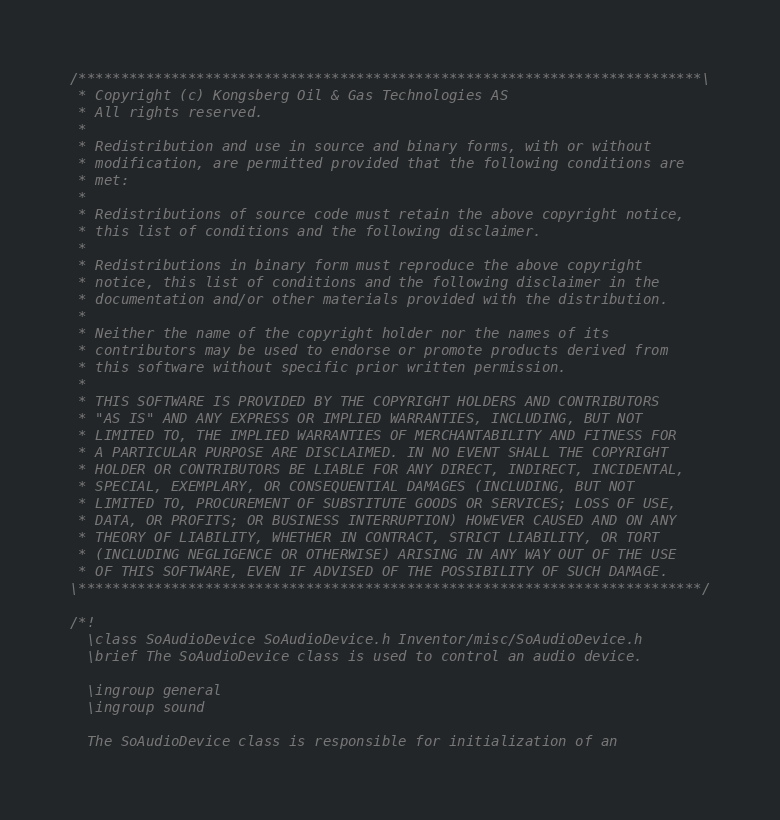<code> <loc_0><loc_0><loc_500><loc_500><_C++_>/**************************************************************************\
 * Copyright (c) Kongsberg Oil & Gas Technologies AS
 * All rights reserved.
 * 
 * Redistribution and use in source and binary forms, with or without
 * modification, are permitted provided that the following conditions are
 * met:
 * 
 * Redistributions of source code must retain the above copyright notice,
 * this list of conditions and the following disclaimer.
 * 
 * Redistributions in binary form must reproduce the above copyright
 * notice, this list of conditions and the following disclaimer in the
 * documentation and/or other materials provided with the distribution.
 * 
 * Neither the name of the copyright holder nor the names of its
 * contributors may be used to endorse or promote products derived from
 * this software without specific prior written permission.
 * 
 * THIS SOFTWARE IS PROVIDED BY THE COPYRIGHT HOLDERS AND CONTRIBUTORS
 * "AS IS" AND ANY EXPRESS OR IMPLIED WARRANTIES, INCLUDING, BUT NOT
 * LIMITED TO, THE IMPLIED WARRANTIES OF MERCHANTABILITY AND FITNESS FOR
 * A PARTICULAR PURPOSE ARE DISCLAIMED. IN NO EVENT SHALL THE COPYRIGHT
 * HOLDER OR CONTRIBUTORS BE LIABLE FOR ANY DIRECT, INDIRECT, INCIDENTAL,
 * SPECIAL, EXEMPLARY, OR CONSEQUENTIAL DAMAGES (INCLUDING, BUT NOT
 * LIMITED TO, PROCUREMENT OF SUBSTITUTE GOODS OR SERVICES; LOSS OF USE,
 * DATA, OR PROFITS; OR BUSINESS INTERRUPTION) HOWEVER CAUSED AND ON ANY
 * THEORY OF LIABILITY, WHETHER IN CONTRACT, STRICT LIABILITY, OR TORT
 * (INCLUDING NEGLIGENCE OR OTHERWISE) ARISING IN ANY WAY OUT OF THE USE
 * OF THIS SOFTWARE, EVEN IF ADVISED OF THE POSSIBILITY OF SUCH DAMAGE.
\**************************************************************************/

/*!
  \class SoAudioDevice SoAudioDevice.h Inventor/misc/SoAudioDevice.h
  \brief The SoAudioDevice class is used to control an audio device.

  \ingroup general
  \ingroup sound

  The SoAudioDevice class is responsible for initialization of an </code> 